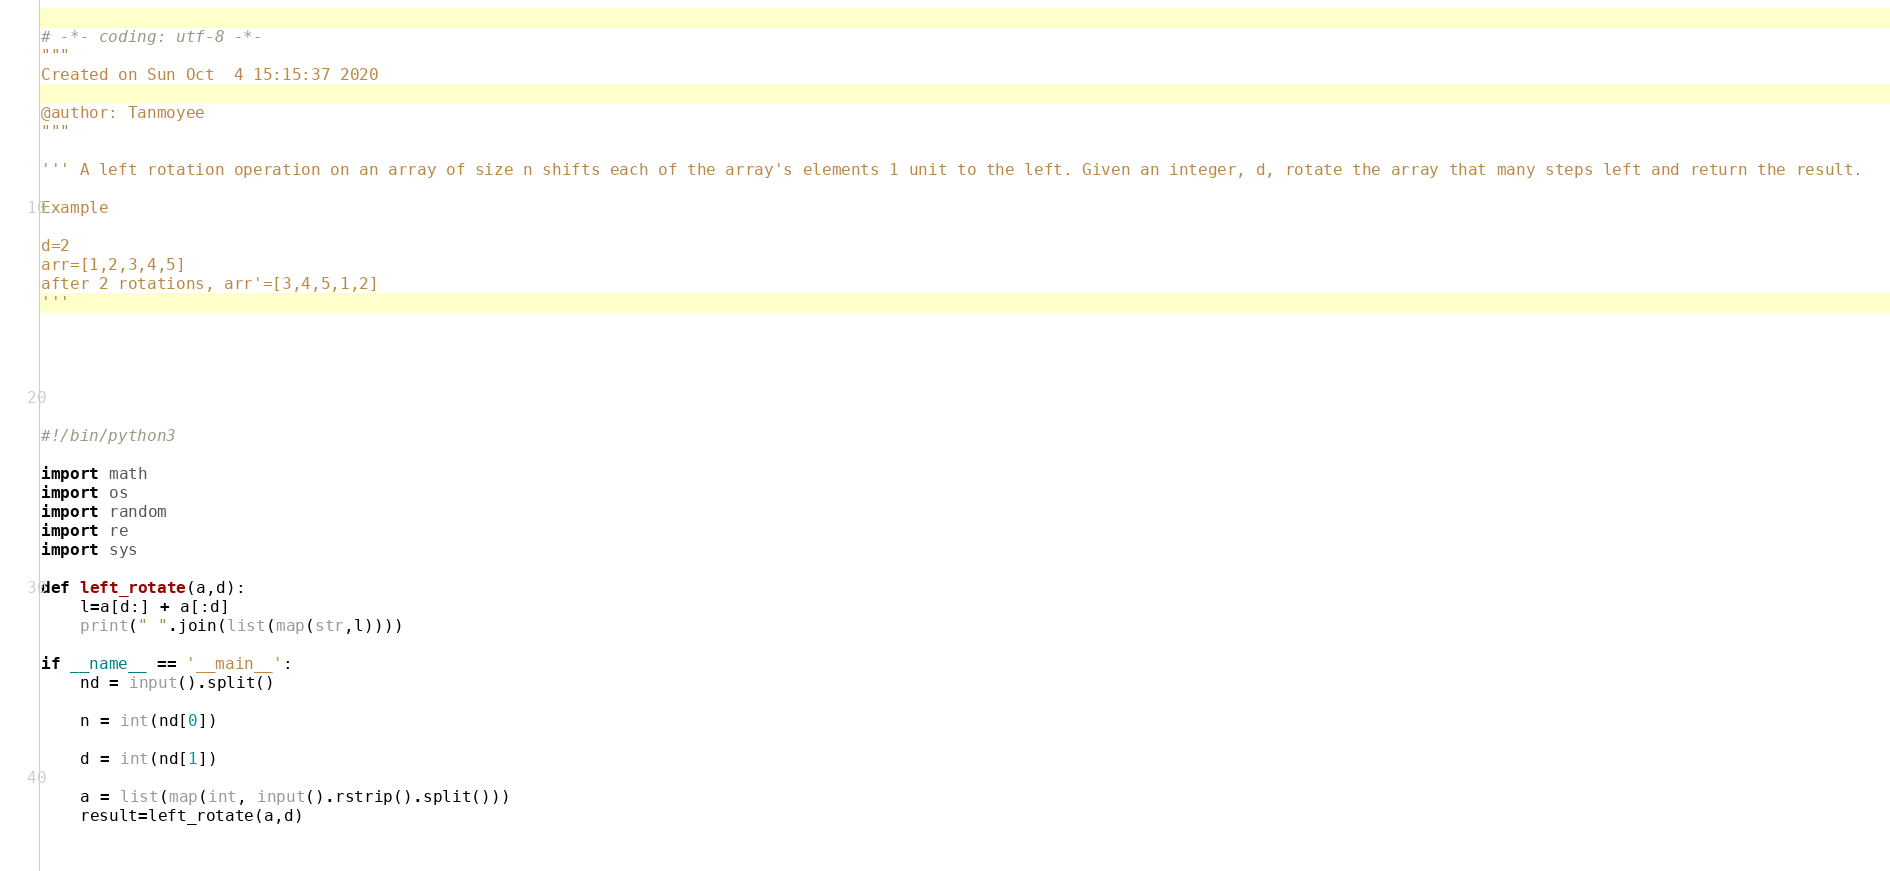<code> <loc_0><loc_0><loc_500><loc_500><_Python_># -*- coding: utf-8 -*-
"""
Created on Sun Oct  4 15:15:37 2020

@author: Tanmoyee
"""

''' A left rotation operation on an array of size n shifts each of the array's elements 1 unit to the left. Given an integer, d, rotate the array that many steps left and return the result.

Example

d=2
arr=[1,2,3,4,5]
after 2 rotations, arr'=[3,4,5,1,2]
'''






#!/bin/python3

import math
import os
import random
import re
import sys

def left_rotate(a,d):
    l=a[d:] + a[:d]
    print(" ".join(list(map(str,l))))

if __name__ == '__main__':
    nd = input().split()

    n = int(nd[0])

    d = int(nd[1])

    a = list(map(int, input().rstrip().split()))
    result=left_rotate(a,d)
    
</code> 